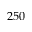<formula> <loc_0><loc_0><loc_500><loc_500>2 5 0</formula> 